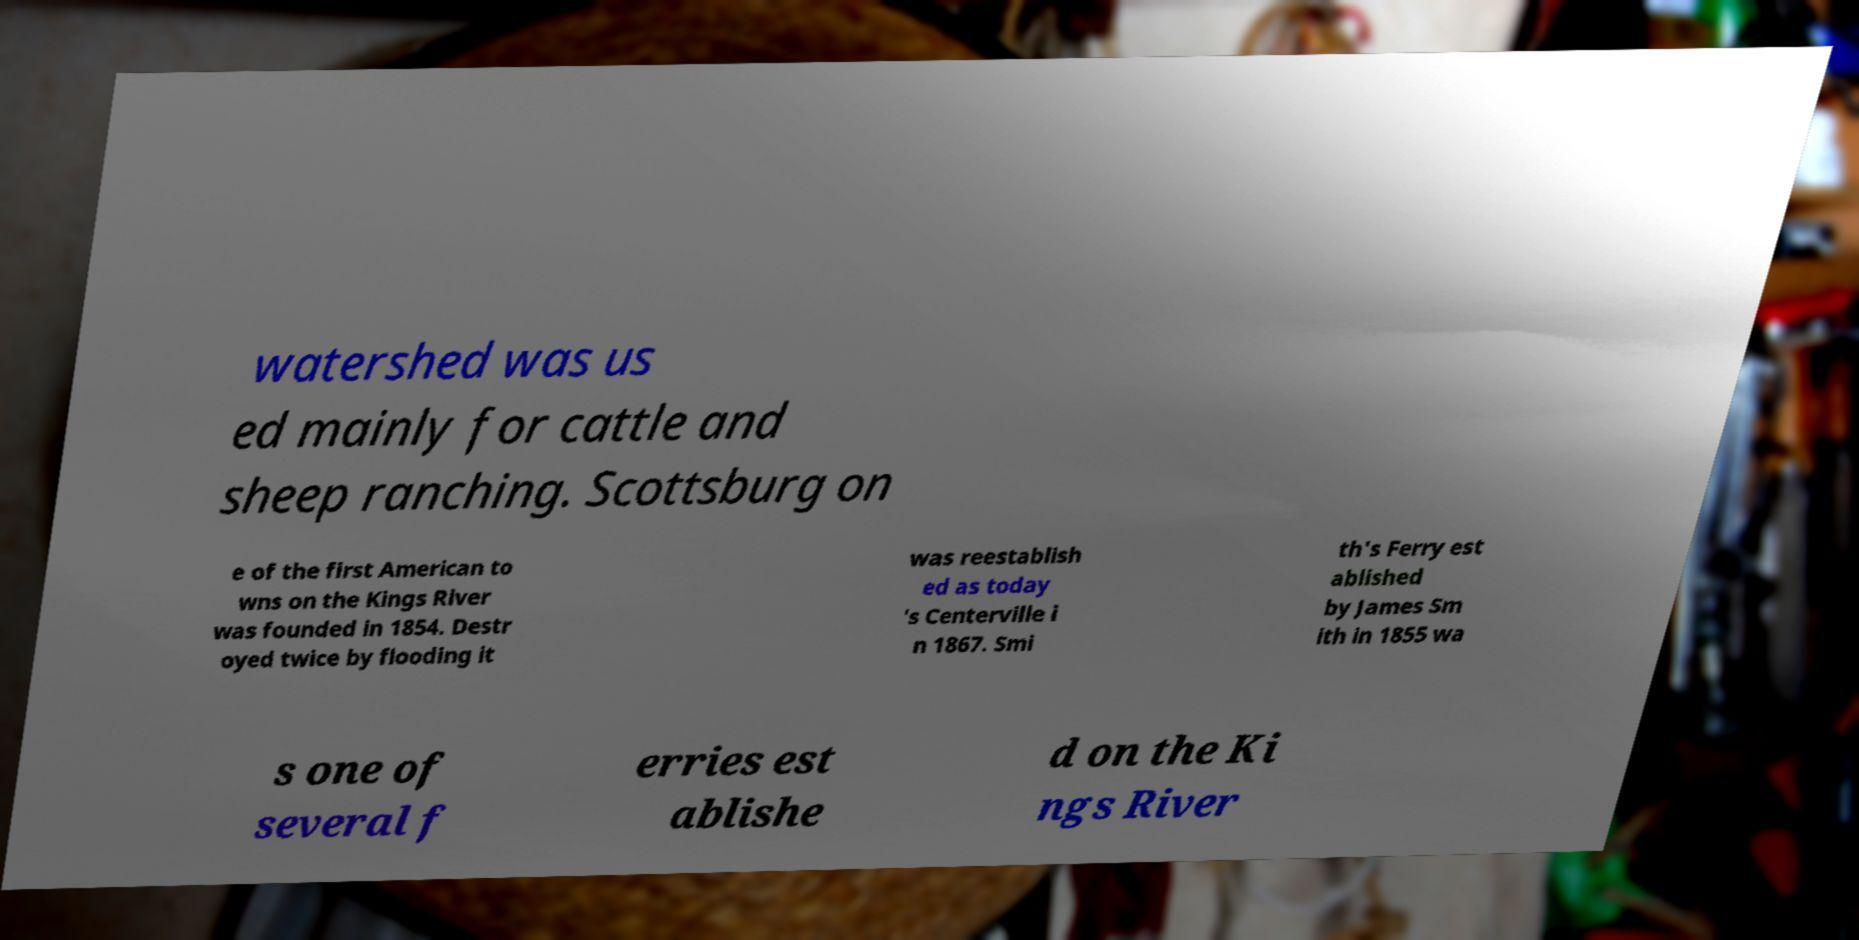Please identify and transcribe the text found in this image. watershed was us ed mainly for cattle and sheep ranching. Scottsburg on e of the first American to wns on the Kings River was founded in 1854. Destr oyed twice by flooding it was reestablish ed as today 's Centerville i n 1867. Smi th's Ferry est ablished by James Sm ith in 1855 wa s one of several f erries est ablishe d on the Ki ngs River 